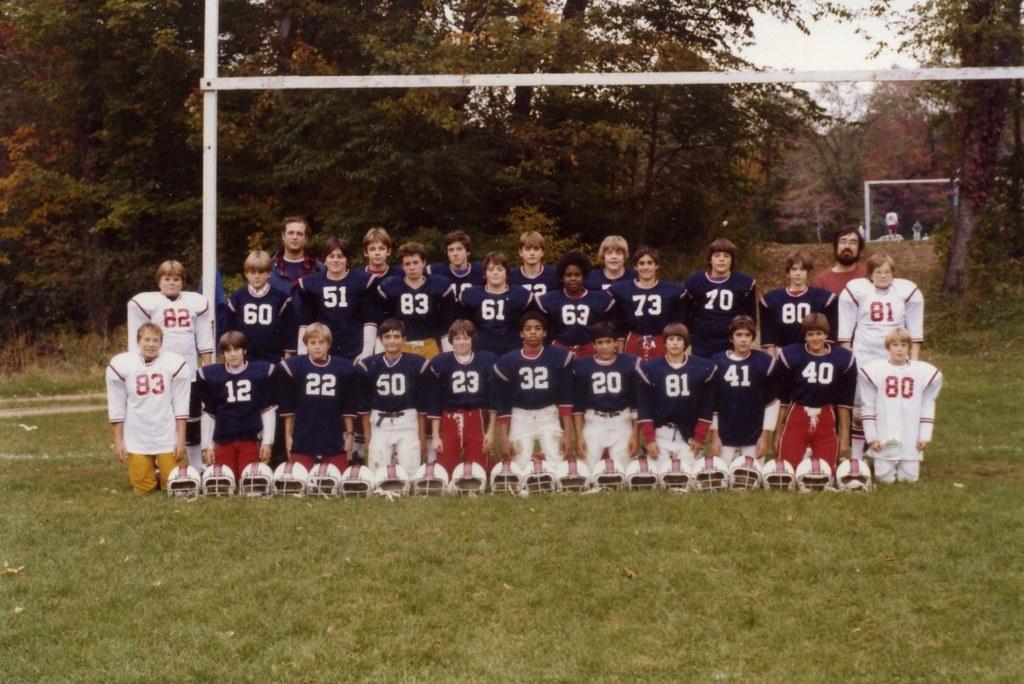What is the player number of the person on the bottom left?
Keep it short and to the point. 83. What is the player number of the person on the bottom right?
Provide a succinct answer. 80. 